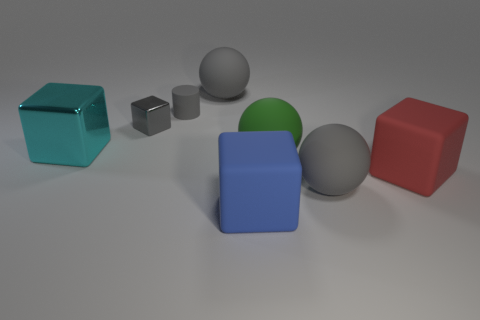Subtract all tiny gray blocks. How many blocks are left? 3 Subtract 3 blocks. How many blocks are left? 1 Add 1 tiny cyan cylinders. How many objects exist? 9 Subtract all gray spheres. How many spheres are left? 1 Subtract all cylinders. How many objects are left? 7 Subtract 0 brown cylinders. How many objects are left? 8 Subtract all cyan cubes. Subtract all yellow cylinders. How many cubes are left? 3 Subtract all brown blocks. How many purple spheres are left? 0 Subtract all big blue shiny cylinders. Subtract all green matte spheres. How many objects are left? 7 Add 3 large red objects. How many large red objects are left? 4 